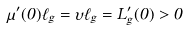Convert formula to latex. <formula><loc_0><loc_0><loc_500><loc_500>\mu ^ { \prime } ( 0 ) \ell _ { g } = \upsilon \ell _ { g } = L _ { g } ^ { \prime } ( 0 ) > 0</formula> 